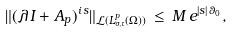Convert formula to latex. <formula><loc_0><loc_0><loc_500><loc_500>\| ( \lambda \, I + A _ { p } ) ^ { i \, s } \| _ { \mathcal { L } ( L ^ { p } _ { \sigma , \tau } ( \Omega ) ) } \, \leq \, M \, e ^ { | s | \, \theta _ { 0 } } ,</formula> 